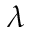<formula> <loc_0><loc_0><loc_500><loc_500>\lambda</formula> 